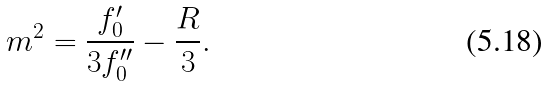Convert formula to latex. <formula><loc_0><loc_0><loc_500><loc_500>m ^ { 2 } = \frac { f _ { 0 } ^ { \prime } } { 3 f _ { 0 } ^ { \prime \prime } } - \frac { R } { 3 } .</formula> 